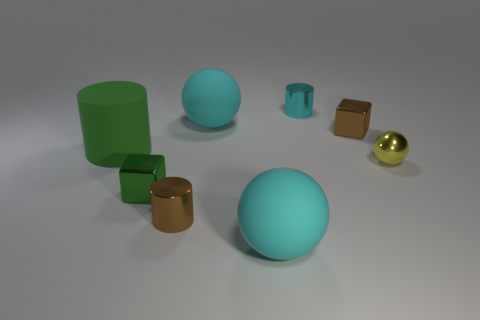How does the color palette in the image affect its mood? The color palette is composed of soft, muted tones, with cyan and earthy colors creating a tranquil and harmonious mood, devoid of any aggressive contrasts. 